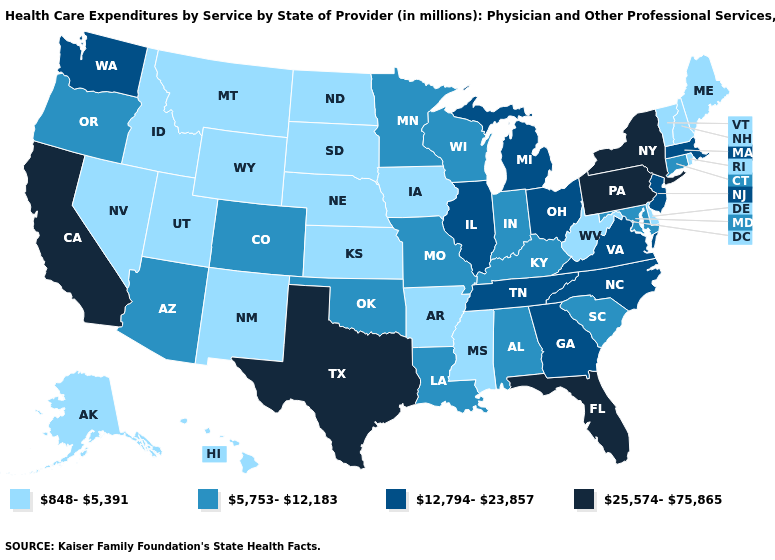Does the map have missing data?
Write a very short answer. No. Among the states that border Kansas , does Nebraska have the highest value?
Be succinct. No. Does Maryland have the highest value in the South?
Give a very brief answer. No. Which states hav the highest value in the West?
Quick response, please. California. What is the highest value in the Northeast ?
Write a very short answer. 25,574-75,865. What is the value of Utah?
Concise answer only. 848-5,391. Name the states that have a value in the range 5,753-12,183?
Concise answer only. Alabama, Arizona, Colorado, Connecticut, Indiana, Kentucky, Louisiana, Maryland, Minnesota, Missouri, Oklahoma, Oregon, South Carolina, Wisconsin. Which states have the lowest value in the West?
Give a very brief answer. Alaska, Hawaii, Idaho, Montana, Nevada, New Mexico, Utah, Wyoming. Which states hav the highest value in the MidWest?
Answer briefly. Illinois, Michigan, Ohio. What is the value of Colorado?
Quick response, please. 5,753-12,183. What is the lowest value in the USA?
Short answer required. 848-5,391. Does Illinois have the same value as New Hampshire?
Be succinct. No. What is the value of Maryland?
Answer briefly. 5,753-12,183. Does Arizona have the highest value in the West?
Quick response, please. No. What is the value of Georgia?
Be succinct. 12,794-23,857. 